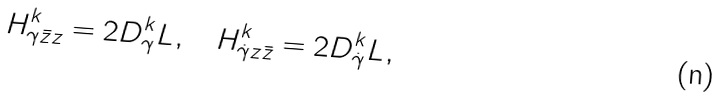Convert formula to latex. <formula><loc_0><loc_0><loc_500><loc_500>H ^ { k } _ { \gamma \bar { z } z } = 2 D ^ { k } _ { \gamma } L , \quad H ^ { k } _ { \dot { \gamma } z \bar { z } } = 2 D ^ { k } _ { \dot { \gamma } } L ,</formula> 